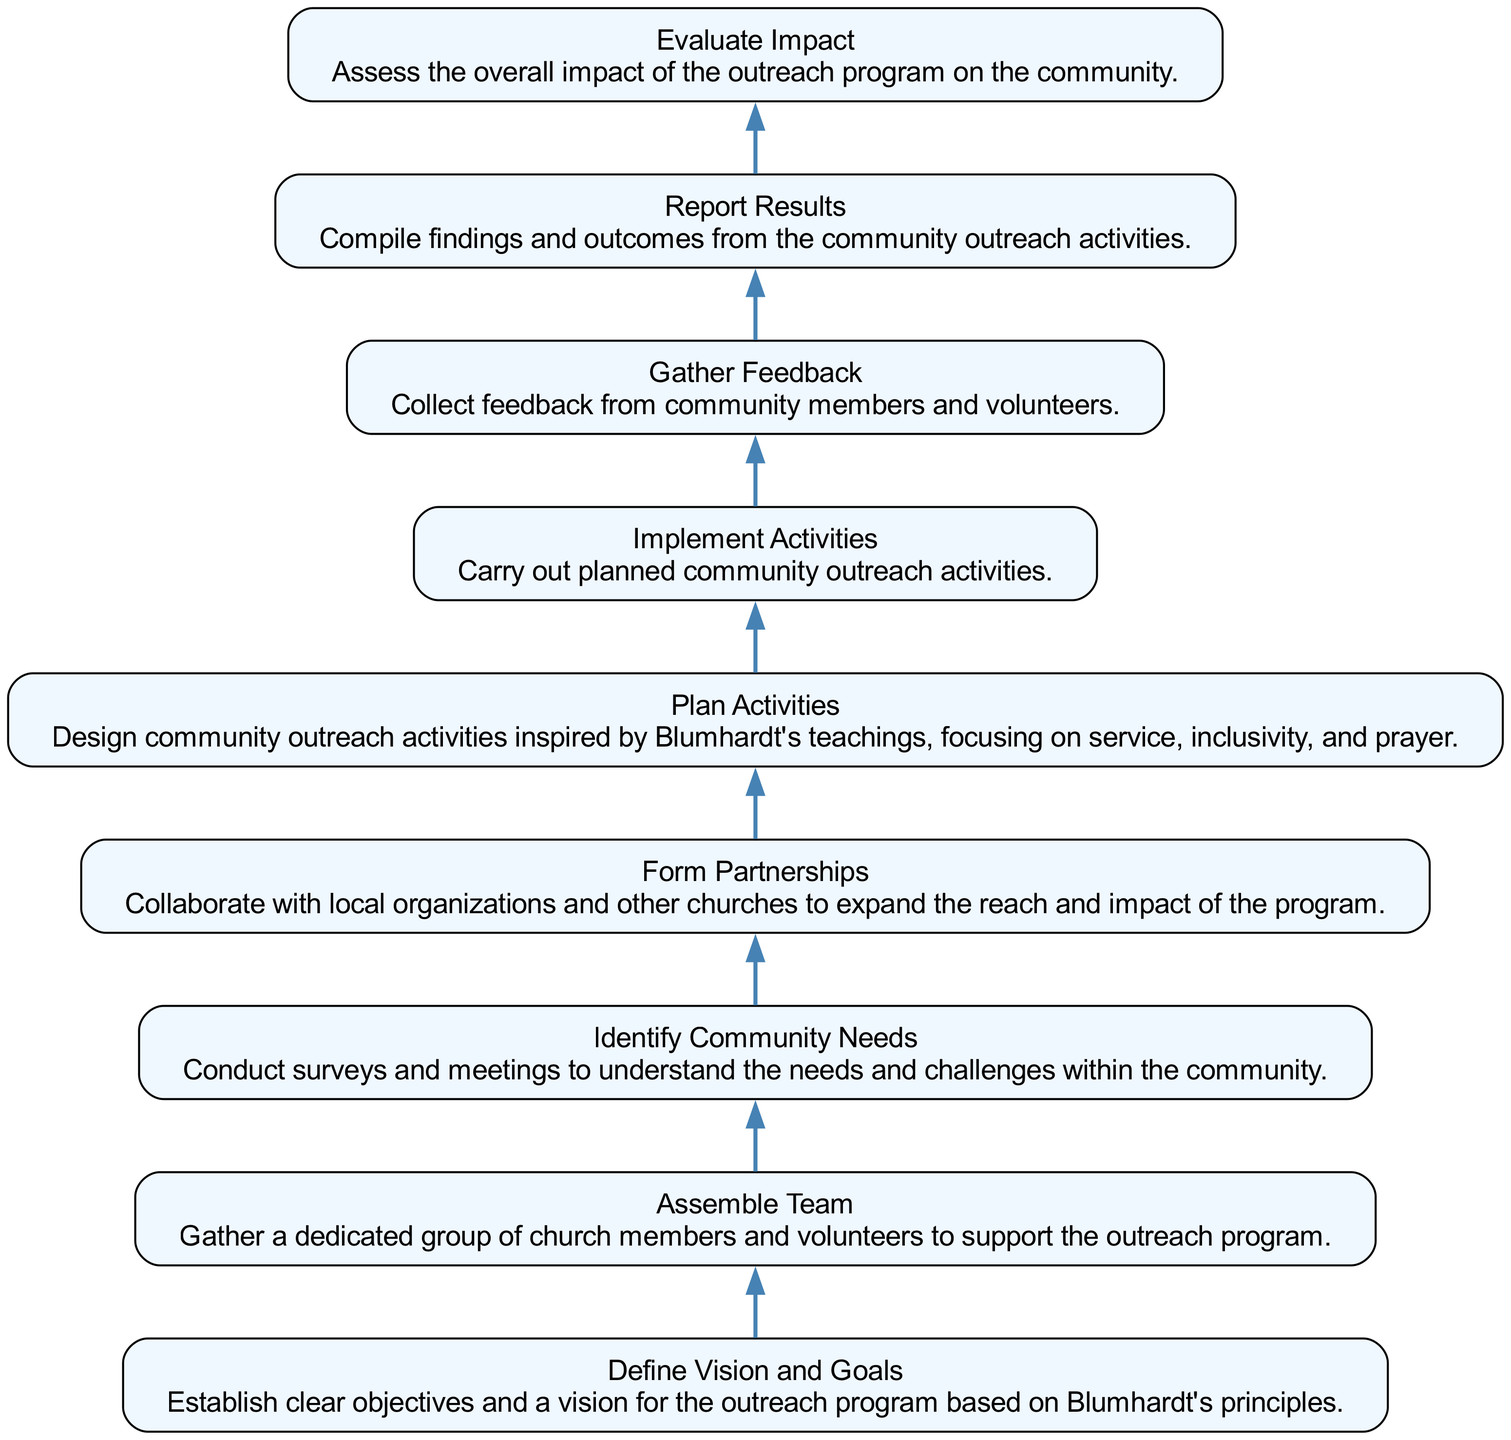What is the first step in the outreach program? The first step is to "Define Vision and Goals," as it has no dependencies and is at the bottom of the flowchart.
Answer: Define Vision and Goals How many nodes are in the flowchart? There are nine nodes in the flowchart, as each of the elements listed represents a distinct step in the program.
Answer: Nine What are the dependencies for "Gather Feedback"? The dependency for "Gather Feedback" is "Implement Activities," which shows the flow of the program from one step to the next.
Answer: Implement Activities How many dependencies does "Plan Activities" have? "Plan Activities" has one dependency, which is "Form Partnerships." This indicates that this step relies on forming collaborations before planning activities.
Answer: One What is the last step in the outreach program? The last step is "Evaluate Impact," as it is positioned at the top of the flowchart and follows the reporting of results.
Answer: Evaluate Impact Which node leads into "Report Results"? The node that leads into "Report Results" is "Gather Feedback," as it collects the necessary input before findings can be compiled.
Answer: Gather Feedback What is the relationship between "Assemble Team" and "Identify Community Needs"? "Assemble Team" is dependent on "Identify Community Needs," meaning that the team must be gathered after understanding community needs.
Answer: Assemble Team depends on Identify Community Needs What inspiration should community outreach activities be based on? The community outreach activities should be inspired by Blumhardt's teachings, which focus on service, inclusivity, and prayer.
Answer: Blumhardt's teachings What is the purpose of "Form Partnerships"? The purpose of "Form Partnerships" is to collaborate with local organizations and other churches, expanding the program's reach and impact in the community.
Answer: Collaborate with local organizations 